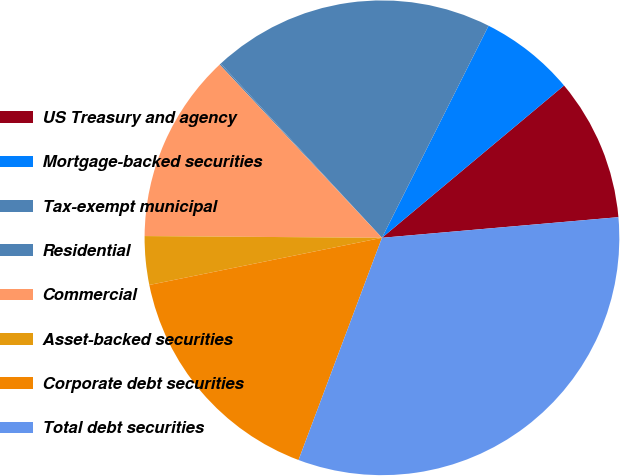<chart> <loc_0><loc_0><loc_500><loc_500><pie_chart><fcel>US Treasury and agency<fcel>Mortgage-backed securities<fcel>Tax-exempt municipal<fcel>Residential<fcel>Commercial<fcel>Asset-backed securities<fcel>Corporate debt securities<fcel>Total debt securities<nl><fcel>9.7%<fcel>6.5%<fcel>19.3%<fcel>0.1%<fcel>12.9%<fcel>3.3%<fcel>16.1%<fcel>32.1%<nl></chart> 